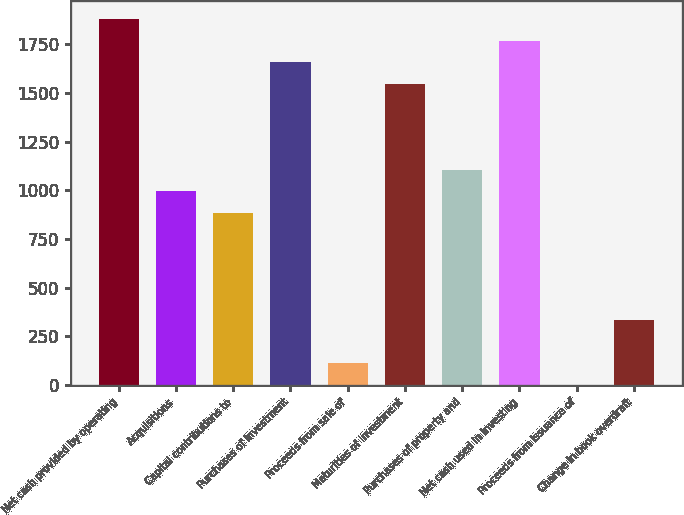<chart> <loc_0><loc_0><loc_500><loc_500><bar_chart><fcel>Net cash provided by operating<fcel>Acquisitions<fcel>Capital contributions to<fcel>Purchases of investment<fcel>Proceeds from sale of<fcel>Maturities of investment<fcel>Purchases of property and<fcel>Net cash used in investing<fcel>Proceeds from issuance of<fcel>Change in book overdraft<nl><fcel>1878.6<fcel>995.64<fcel>885.27<fcel>1657.86<fcel>112.68<fcel>1547.49<fcel>1106.01<fcel>1768.23<fcel>2.31<fcel>333.42<nl></chart> 